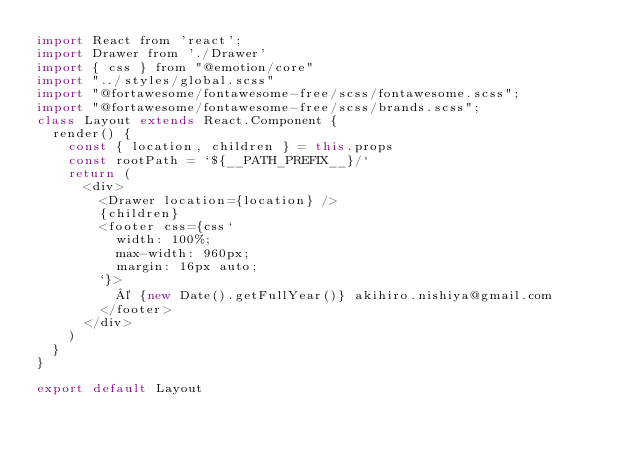<code> <loc_0><loc_0><loc_500><loc_500><_JavaScript_>import React from 'react';
import Drawer from './Drawer'
import { css } from "@emotion/core"
import "../styles/global.scss"
import "@fortawesome/fontawesome-free/scss/fontawesome.scss";
import "@fortawesome/fontawesome-free/scss/brands.scss";
class Layout extends React.Component {
  render() {
    const { location, children } = this.props
    const rootPath = `${__PATH_PREFIX__}/`
    return (
      <div>
        <Drawer location={location} />
        {children}
        <footer css={css`
          width: 100%;
          max-width: 960px;
          margin: 16px auto;
        `}>
          © {new Date().getFullYear()} akihiro.nishiya@gmail.com
        </footer>
      </div>
    )
  }
}

export default Layout
</code> 